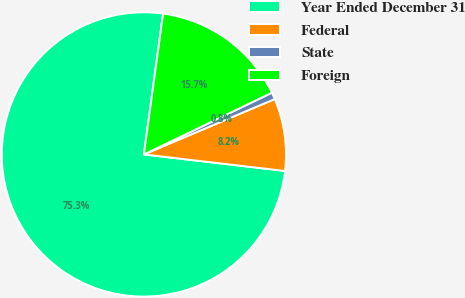Convert chart to OTSL. <chart><loc_0><loc_0><loc_500><loc_500><pie_chart><fcel>Year Ended December 31<fcel>Federal<fcel>State<fcel>Foreign<nl><fcel>75.3%<fcel>8.23%<fcel>0.78%<fcel>15.69%<nl></chart> 